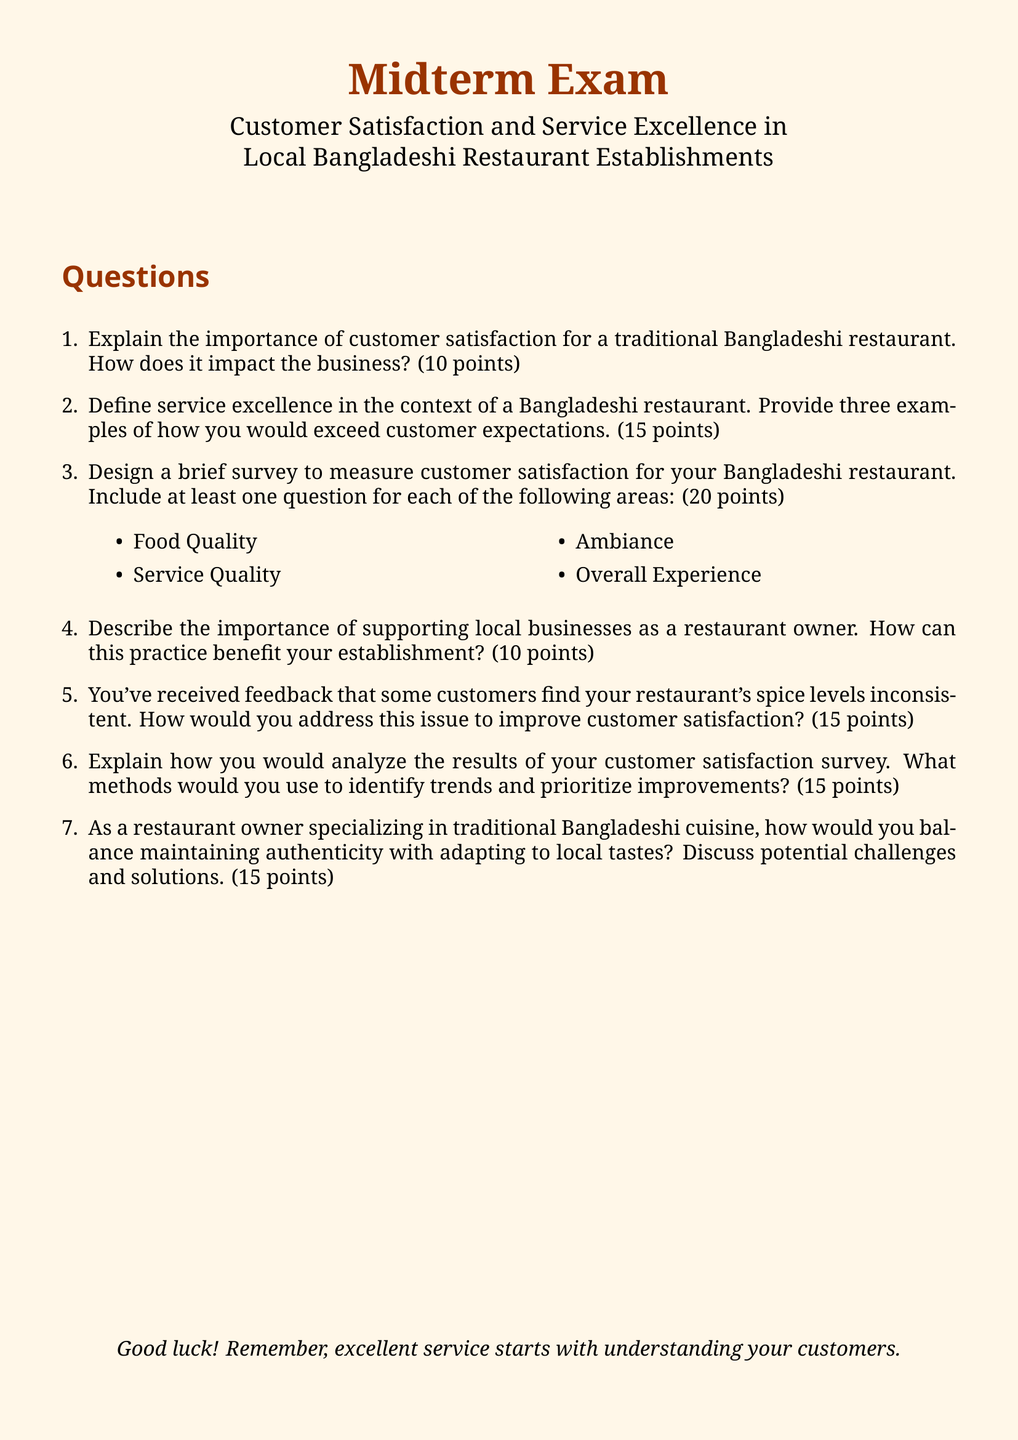What is the maximum score for Question 1? The maximum score for Question 1, which asks about the importance of customer satisfaction, is mentioned in the document.
Answer: 10 points What are the four areas included in the survey design question? The document lists four areas in the survey that should be measured for customer satisfaction.
Answer: Food Quality, Service Quality, Ambiance, Overall Experience How many points are assigned to Question 3? The document specifies the points assigned to Question 3, which involves designing a survey.
Answer: 20 points What is the total score for all the questions in the exam? The total score can be calculated by summing the points assigned to all individual questions outlined in the document.
Answer: 100 points What is mentioned as a common feedback issue from customers? The document addresses a specific feedback issue regarding customer satisfaction related to spice levels.
Answer: Inconsistent spice levels What is the title of the document? The title clearly states the focus of the midterm exam related to customer satisfaction in restaurants.
Answer: Midterm Exam: Customer Satisfaction and Service Excellence in Local Bangladeshi Restaurant Establishments What is the overall theme of the midterm exam? The document summarizes the main focus of the exam, connecting it to the restaurant sector and customer experience.
Answer: Customer Satisfaction and Service Excellence What is the required length to explain service excellence in the context of a Bangladeshi restaurant? The document indicates the number of points that can be earned by explaining service excellence.
Answer: 15 points 